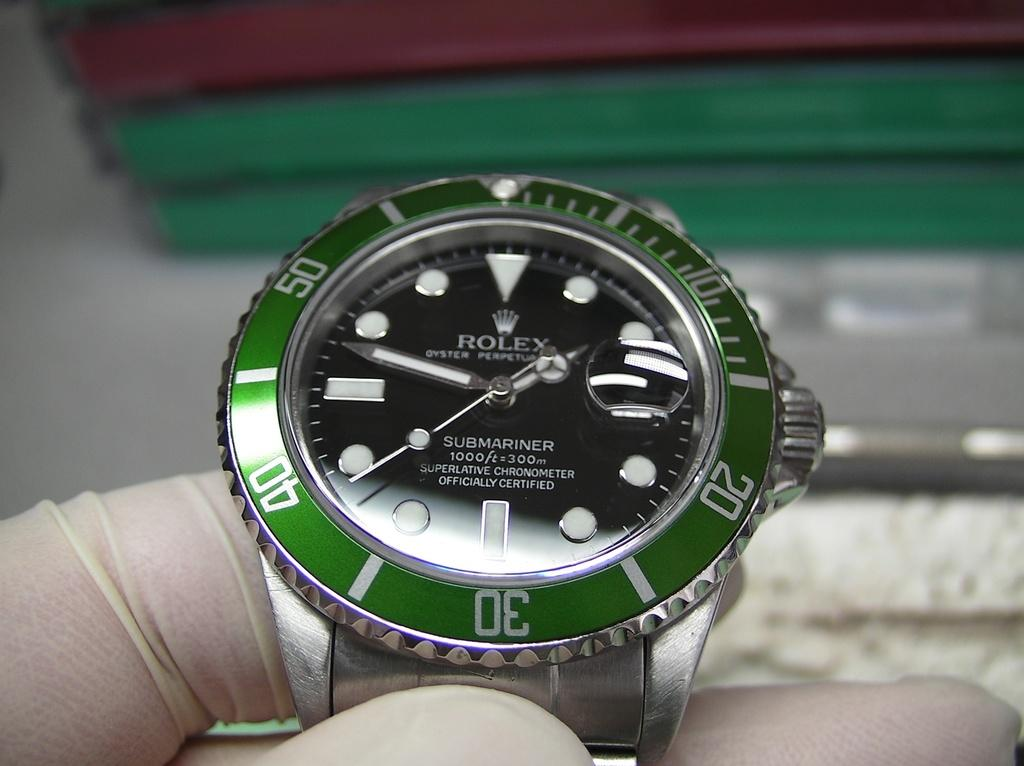<image>
Create a compact narrative representing the image presented. A silver and green ROLEX wrist watch held in a gloved hand. 